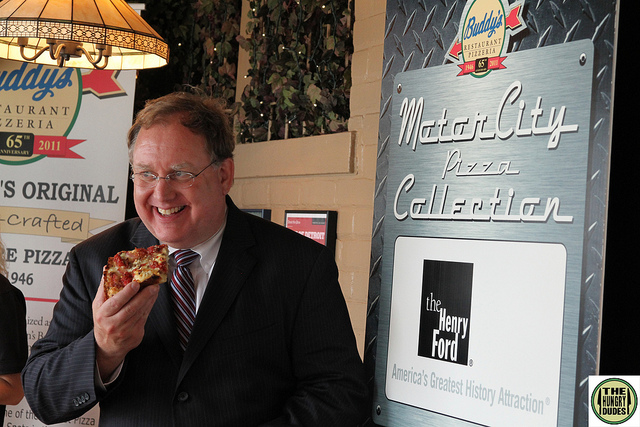Please extract the text content from this image. MotorCity Pizza Collection Ford Greatest e OF PIZZA 946 PIZZA E -Crafted ORIGINAL S 2011 65 ZERIA AURANT PIZZARIA RESTAURENT Buddy's DUDES HUNGRT THE Attraction History America's Henry the 